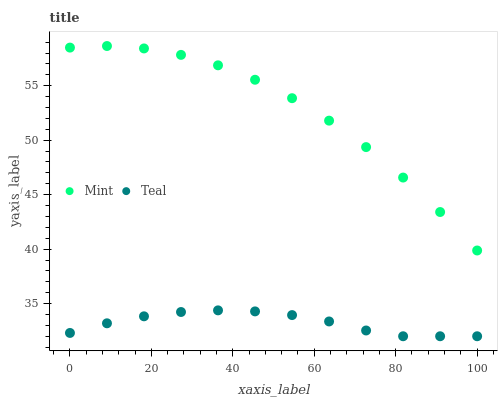Does Teal have the minimum area under the curve?
Answer yes or no. Yes. Does Mint have the maximum area under the curve?
Answer yes or no. Yes. Does Teal have the maximum area under the curve?
Answer yes or no. No. Is Teal the smoothest?
Answer yes or no. Yes. Is Mint the roughest?
Answer yes or no. Yes. Is Teal the roughest?
Answer yes or no. No. Does Teal have the lowest value?
Answer yes or no. Yes. Does Mint have the highest value?
Answer yes or no. Yes. Does Teal have the highest value?
Answer yes or no. No. Is Teal less than Mint?
Answer yes or no. Yes. Is Mint greater than Teal?
Answer yes or no. Yes. Does Teal intersect Mint?
Answer yes or no. No. 